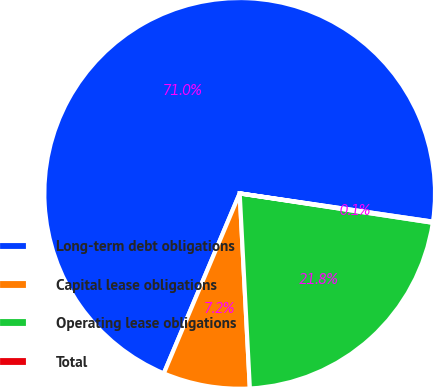<chart> <loc_0><loc_0><loc_500><loc_500><pie_chart><fcel>Long-term debt obligations<fcel>Capital lease obligations<fcel>Operating lease obligations<fcel>Total<nl><fcel>70.96%<fcel>7.18%<fcel>21.77%<fcel>0.09%<nl></chart> 